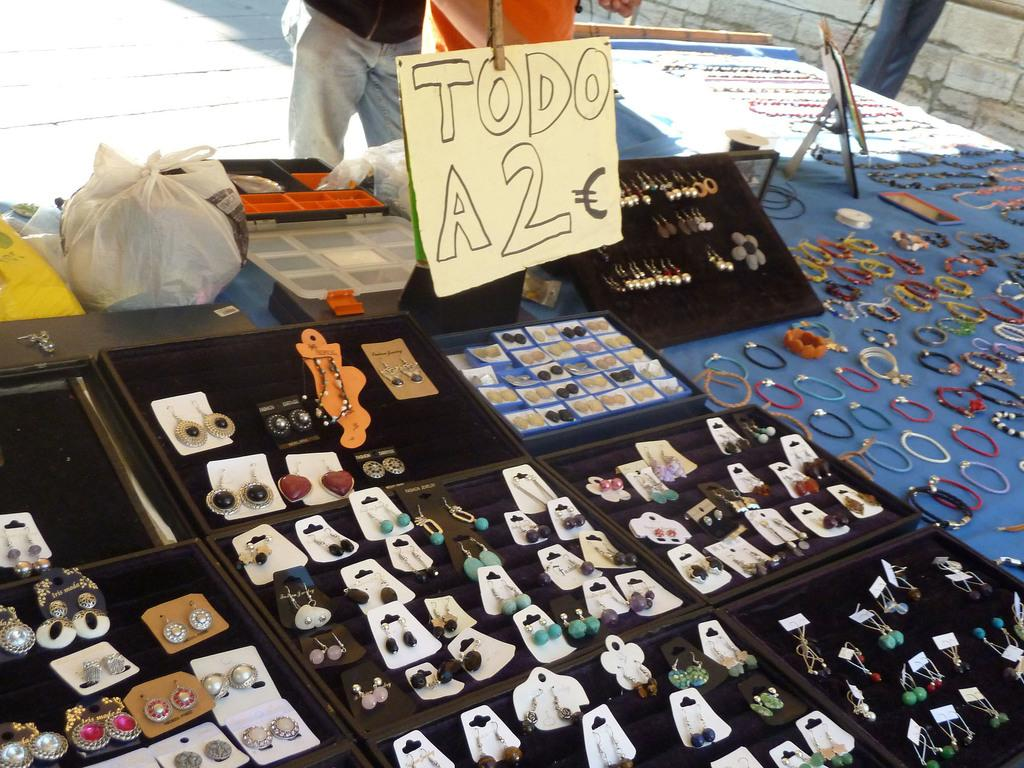What type of jewelry is visible in the image? There are earrings and bangles in the image. Where are the earrings and bangles located? The earrings and bangles are placed on a table. Can you describe the background of the image? There are persons and a floor visible in the background of the image. What type of grass is growing on the stranger's head in the image? There is no stranger or grass present in the image; it only features earrings, bangles, and a table. 